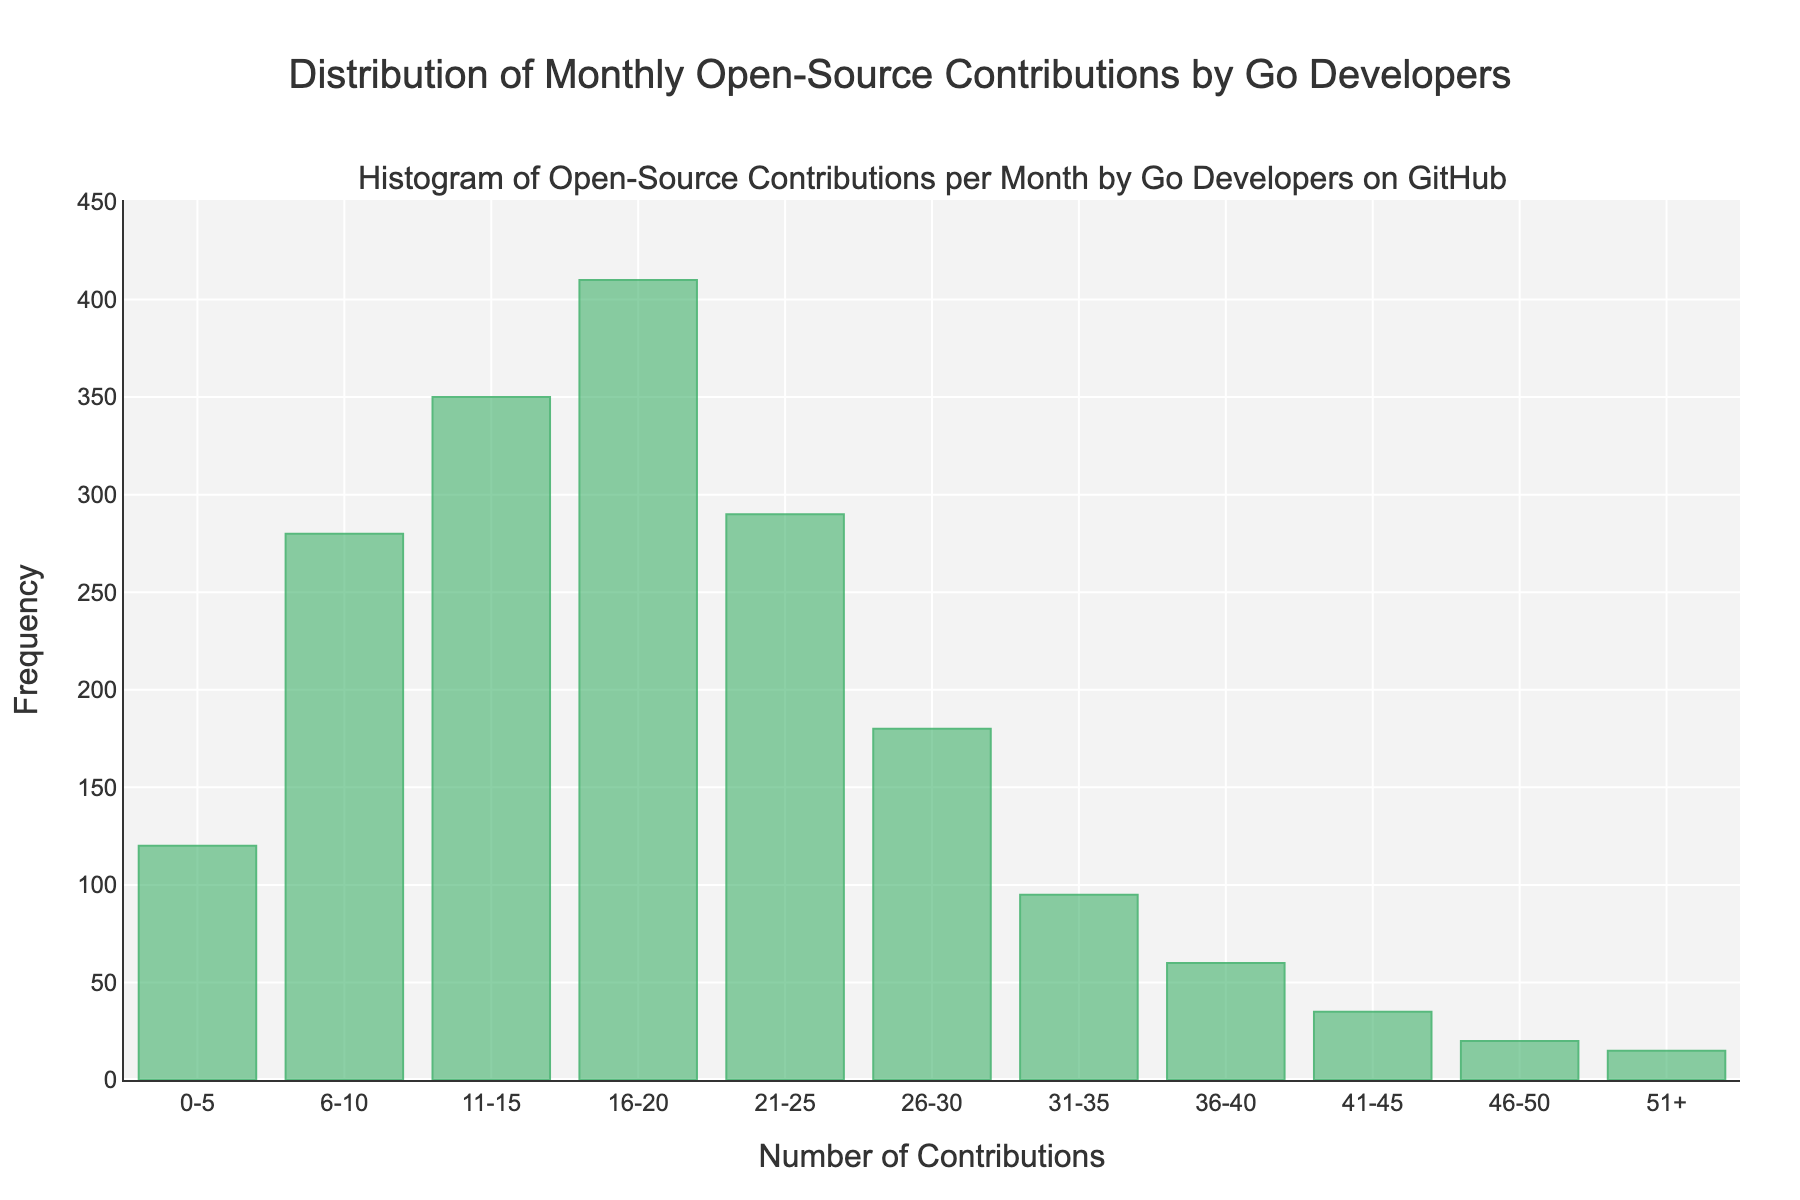What is the title of the histogram? The title is located at the top of the histogram and reads "Distribution of Monthly Open-Source Contributions by Go Developers".
Answer: Distribution of Monthly Open-Source Contributions by Go Developers What range of contributions has the highest frequency? Looking at the histogram bars, the tallest bar corresponds to the range with the highest frequency. The range 16-20 has the tallest bar indicating it has the highest frequency.
Answer: 16-20 How many developers contributed between 26 and 30 times in a month? The height of the bar corresponding to the range 26-30 on the x-axis determines the frequency. It is equal to 180 as shown on the y-axis.
Answer: 180 What is the total frequency of developers contributing more than 30 times in a month? To find the total, we add the frequencies of the ranges 31-35 (95), 36-40 (60), 41-45 (35), 46-50 (20), and 51+ (15). The sum is 95 + 60 + 35 + 20 + 15.
Answer: 225 Which contribution range has the lowest frequency? The bar with the shortest height on the histogram indicates the lowest frequency. The 51+ contributions range has the shortest bar.
Answer: 51+ How does the frequency of contributions in the range 0-5 compare to the range 11-15? Check the heights of the bars for both ranges. The 0-5 range has a frequency of 120, while the 11-15 range has a frequency of 350. The 11-15 range is higher.
Answer: The 11-15 range is higher What is the total number of developers included in the histogram? Sum all the frequency values from each range: 120 + 280 + 350 + 410 + 290 + 180 + 95 + 60 + 35 + 20 + 15.
Answer: 1855 What percentage of the total developers contributed between 16-20 times in a month? First, calculate the total number of developers, which is 1855. The frequency for the 16-20 range is 410. The percentage is calculated as (410 / 1855) * 100.
Answer: 22.10% Which frequency range saw more contributions, 21-25 or 6-10? Compare the heights of the bars for these ranges. The 21-25 range's frequency is 290, and the 6-10 range's frequency is 280. The 21-25 range is higher.
Answer: The 21-25 range is higher 